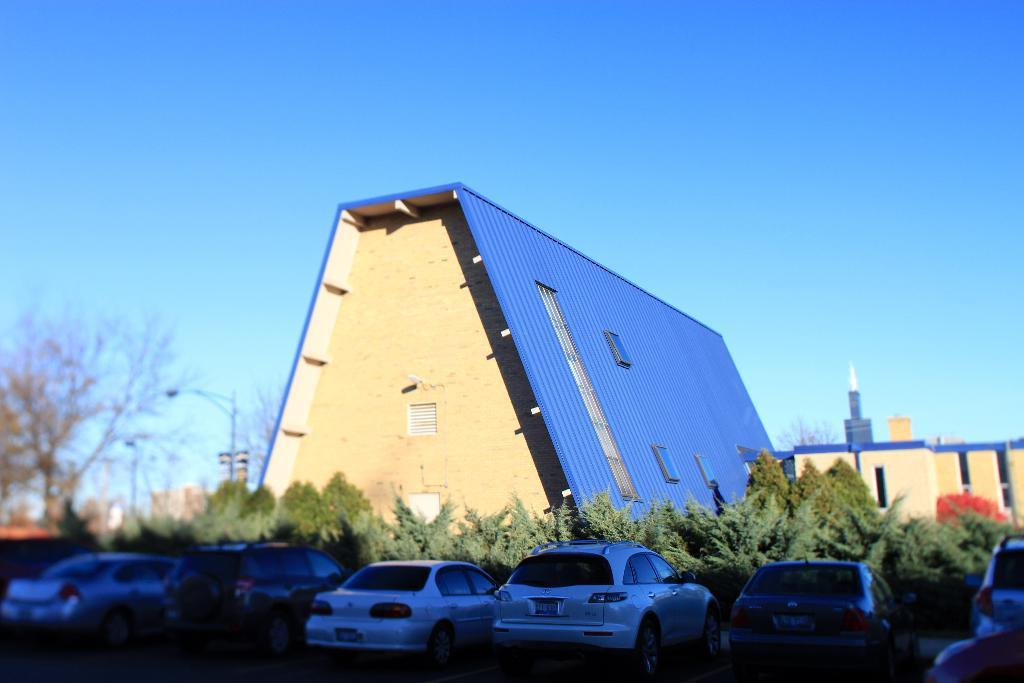What type of structures are present in the image? There are buildings in the image. What feature do the buildings have? The buildings have windows. What other objects can be seen in the image? There are trees, light poles, and vehicles in the image. What is the color of the sky in the image? The sky is blue and white in color. Where is the pot located in the image? There is no pot present in the image. What type of sink can be seen in the image? There is no sink present in the image. 